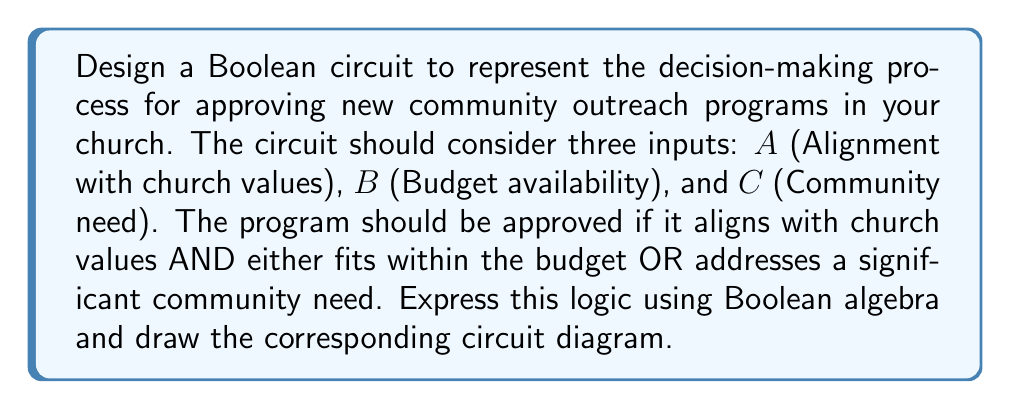Can you solve this math problem? Let's approach this step-by-step:

1. First, we need to express the logic in Boolean algebra. The program should be approved if:
   - It aligns with church values (A) AND
   - Either fits within the budget (B) OR addresses a significant community need (C)

   This can be expressed as: $F = A \cdot (B + C)$

2. To design the circuit, we need to break this down into basic logic gates:
   - We need an OR gate for (B + C)
   - We need an AND gate to combine A with the result of (B + C)

3. The circuit diagram can be drawn as follows:

[asy]
import geometry;

// Define points
pair A = (0,60);
pair B = (0,30);
pair C = (0,0);
pair OR = (60,15);
pair AND = (120,45);
pair F = (180,45);

// Draw input lines
draw(A--(60,60));
draw(B--OR);
draw(C--OR);

// Draw OR gate
path orGate = (50,0)--(50,30)--(70,15)--cycle;
fill(orGate, gray(0.9));
draw(orGate);

// Draw AND gate
path andGate = (110,30){right}..{down}(130,45){down}..{left}(110,60)--cycle;
fill(andGate, gray(0.9));
draw(andGate);

// Draw output lines
draw(OR--(100,15)--(100,30));
draw((60,60)--(100,60));
draw(AND--F);

// Label points
label("A", A, W);
label("B", B, W);
label("C", C, W);
label("F", F, E);

// Label gates
label("OR", (60,15), S);
label("AND", (120,45), S);
[/asy]

4. In this circuit:
   - Inputs B and C go into the OR gate
   - The output of the OR gate and input A go into the AND gate
   - The output of the AND gate is our final result F

5. This circuit implements the Boolean function $F = A \cdot (B + C)$, which represents our decision-making process for approving new community outreach programs.
Answer: $F = A \cdot (B + C)$ 